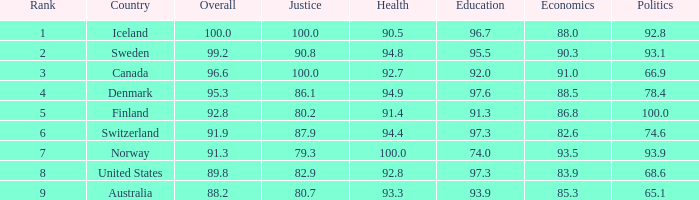4? Finland. 